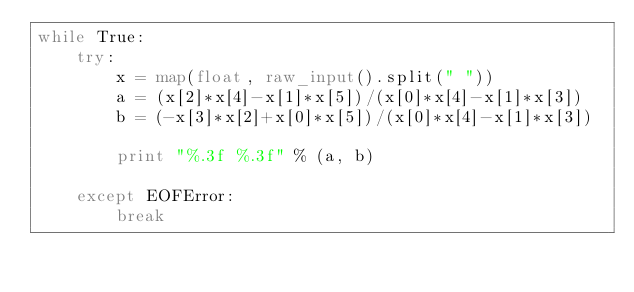<code> <loc_0><loc_0><loc_500><loc_500><_Python_>while True:
    try:
        x = map(float, raw_input().split(" "))
        a = (x[2]*x[4]-x[1]*x[5])/(x[0]*x[4]-x[1]*x[3])
        b = (-x[3]*x[2]+x[0]*x[5])/(x[0]*x[4]-x[1]*x[3])
        
        print "%.3f %.3f" % (a, b)
    
    except EOFError:
        break</code> 